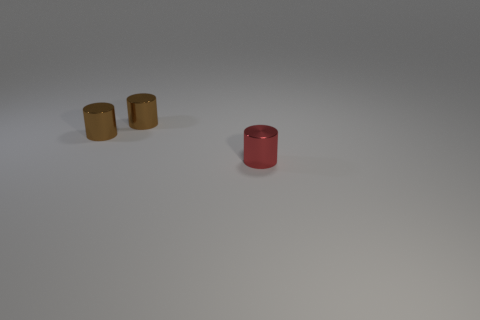Are there any large blue rubber things that have the same shape as the tiny red metal object?
Offer a terse response. No. What number of red cylinders are made of the same material as the red thing?
Offer a very short reply. 0. What number of things are brown metallic cylinders or metallic objects that are on the left side of the small red cylinder?
Make the answer very short. 2. What number of brown things are either tiny metal things or large cylinders?
Your answer should be compact. 2. What number of big objects are red metallic things or metal cylinders?
Your answer should be very brief. 0. Is the number of big yellow matte balls less than the number of tiny red cylinders?
Your answer should be compact. Yes. Is there anything else that has the same shape as the red shiny object?
Provide a succinct answer. Yes. Are there more metallic things than small brown metal cylinders?
Your response must be concise. Yes. How many other things are made of the same material as the red thing?
Ensure brevity in your answer.  2. How many brown things have the same size as the red shiny cylinder?
Provide a short and direct response. 2. 